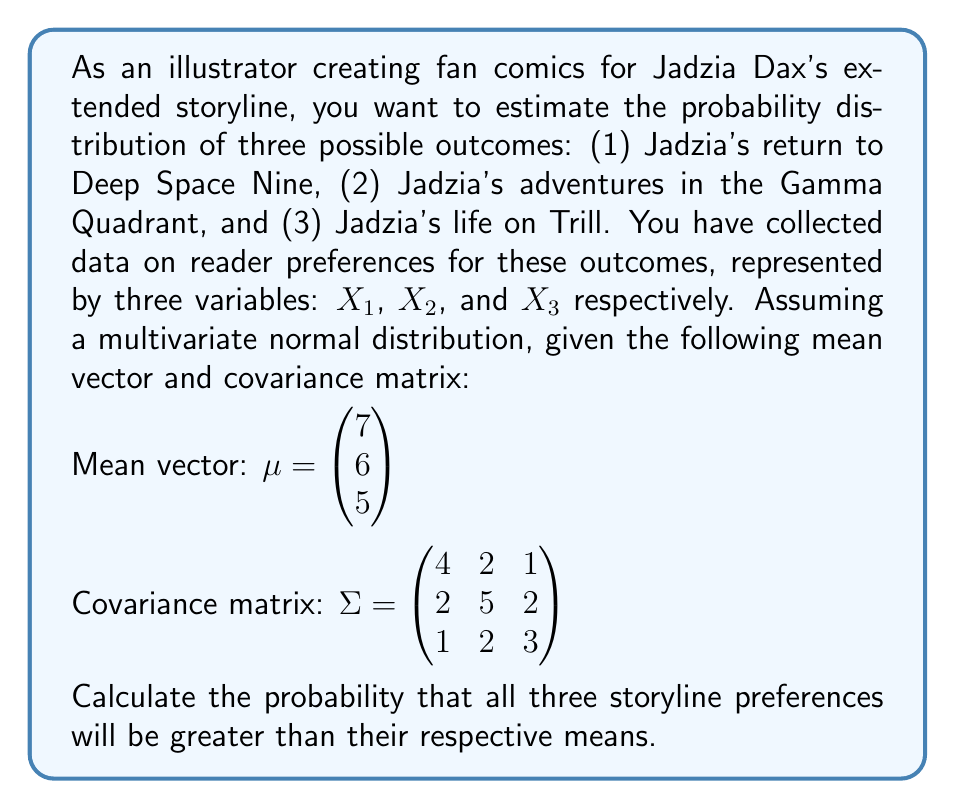Give your solution to this math problem. To solve this problem, we need to use the properties of the multivariate normal distribution and the concept of standardization.

1) First, we need to standardize the variables. Let $Z_1$, $Z_2$, and $Z_3$ be the standardized versions of $X_1$, $X_2$, and $X_3$ respectively. We're interested in:

   $P(X_1 > 7, X_2 > 6, X_3 > 5)$

   This is equivalent to:

   $P(Z_1 > 0, Z_2 > 0, Z_3 > 0)$

2) For a multivariate normal distribution, the correlation matrix $R$ is derived from the covariance matrix $\Sigma$ as follows:

   $R_{ij} = \frac{\Sigma_{ij}}{\sqrt{\Sigma_{ii}\Sigma_{jj}}}$

3) Calculating the correlation matrix:

   $R = \begin{pmatrix} 
   1 & \frac{2}{\sqrt{4 \cdot 5}} & \frac{1}{\sqrt{4 \cdot 3}} \\
   \frac{2}{\sqrt{4 \cdot 5}} & 1 & \frac{2}{\sqrt{5 \cdot 3}} \\
   \frac{1}{\sqrt{4 \cdot 3}} & \frac{2}{\sqrt{5 \cdot 3}} & 1
   \end{pmatrix}$

   $R = \begin{pmatrix} 
   1 & 0.4472 & 0.2887 \\
   0.4472 & 1 & 0.5164 \\
   0.2887 & 0.5164 & 1
   \end{pmatrix}$

4) The probability we're looking for is the integral of the multivariate normal density function over the region where all variables are greater than their means. This is equivalent to the probability that a random vector from a standard multivariate normal distribution with the given correlation matrix falls in the positive orthant.

5) Unfortunately, there's no closed-form solution for this probability. We need to use numerical methods or look up tables for trivariate normal probabilities. Using a statistical software or appropriate tables, we can find that for a trivariate standard normal distribution with the correlation matrix R, the probability of all variables being positive is approximately 0.1496.
Answer: The probability that all three storyline preferences will be greater than their respective means is approximately 0.1496 or 14.96%. 